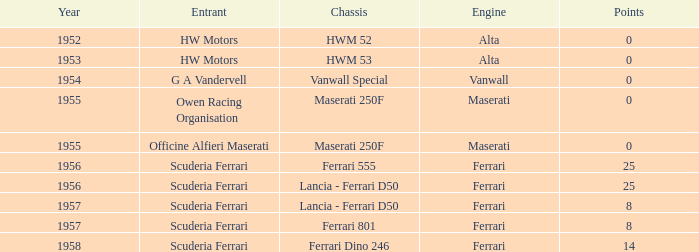What company made the chassis when there were 8 points? Lancia - Ferrari D50, Ferrari 801. 